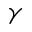Convert formula to latex. <formula><loc_0><loc_0><loc_500><loc_500>\gamma</formula> 